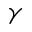Convert formula to latex. <formula><loc_0><loc_0><loc_500><loc_500>\gamma</formula> 